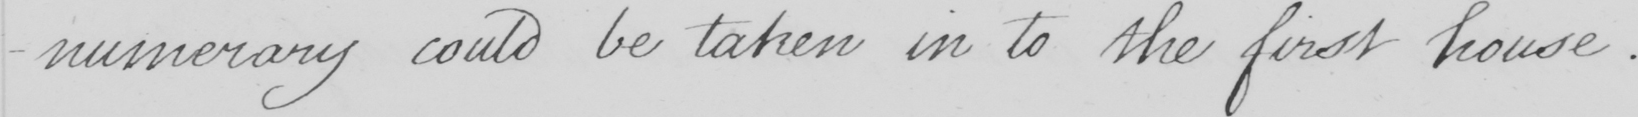Can you tell me what this handwritten text says? -numerary could be taken in to the first house . 